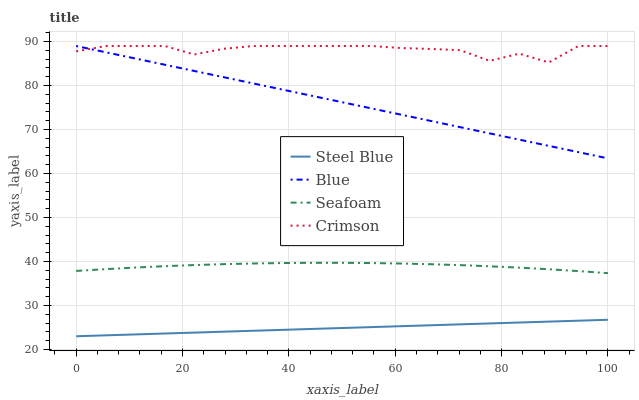Does Crimson have the minimum area under the curve?
Answer yes or no. No. Does Steel Blue have the maximum area under the curve?
Answer yes or no. No. Is Crimson the smoothest?
Answer yes or no. No. Is Steel Blue the roughest?
Answer yes or no. No. Does Crimson have the lowest value?
Answer yes or no. No. Does Steel Blue have the highest value?
Answer yes or no. No. Is Steel Blue less than Seafoam?
Answer yes or no. Yes. Is Blue greater than Seafoam?
Answer yes or no. Yes. Does Steel Blue intersect Seafoam?
Answer yes or no. No. 